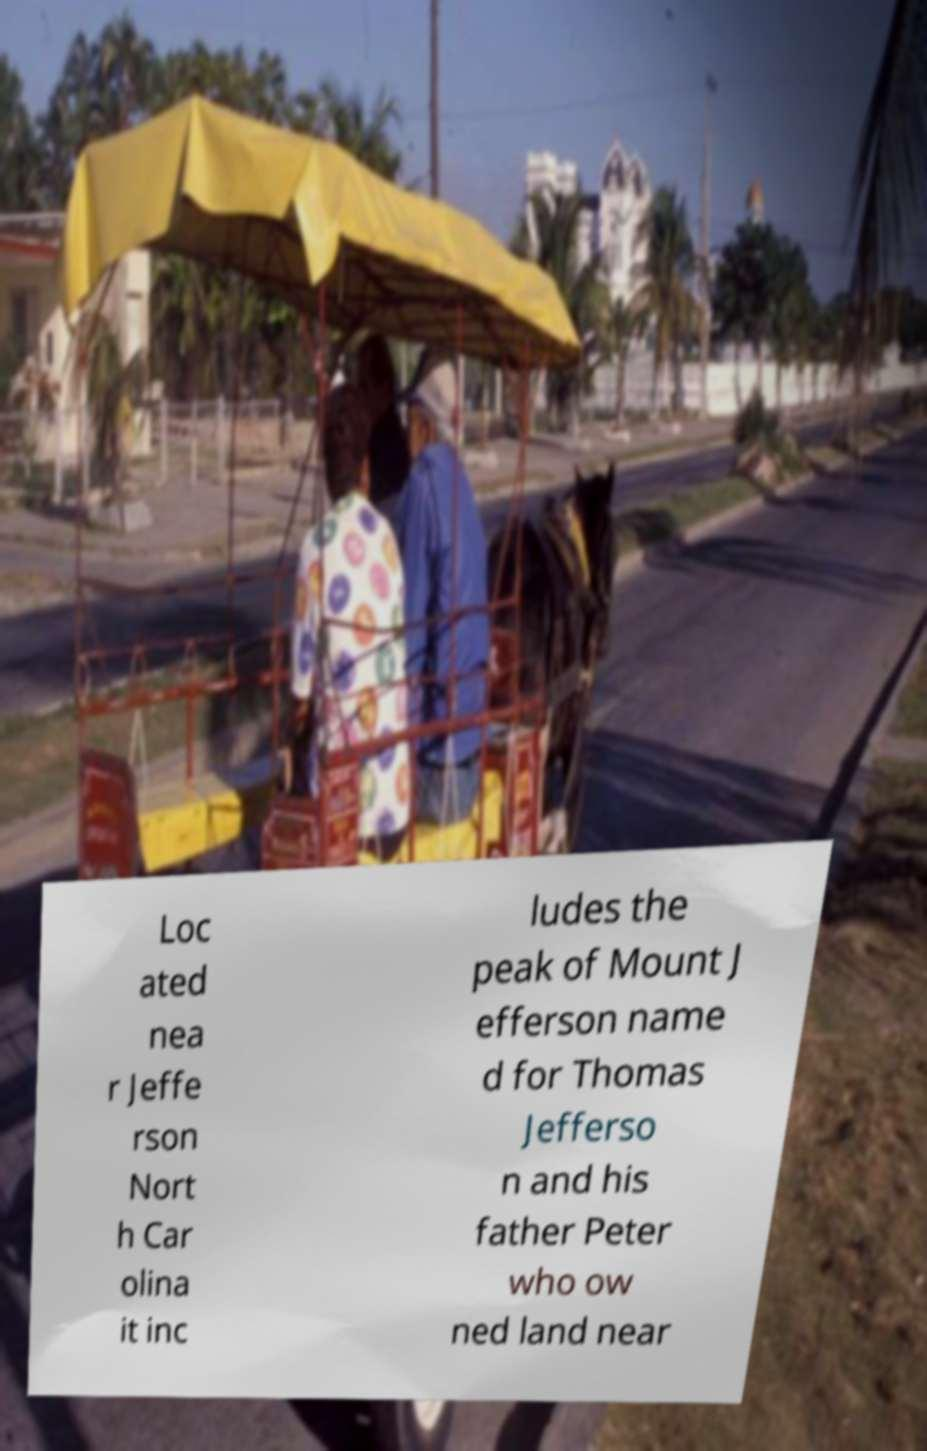Can you read and provide the text displayed in the image?This photo seems to have some interesting text. Can you extract and type it out for me? Loc ated nea r Jeffe rson Nort h Car olina it inc ludes the peak of Mount J efferson name d for Thomas Jefferso n and his father Peter who ow ned land near 